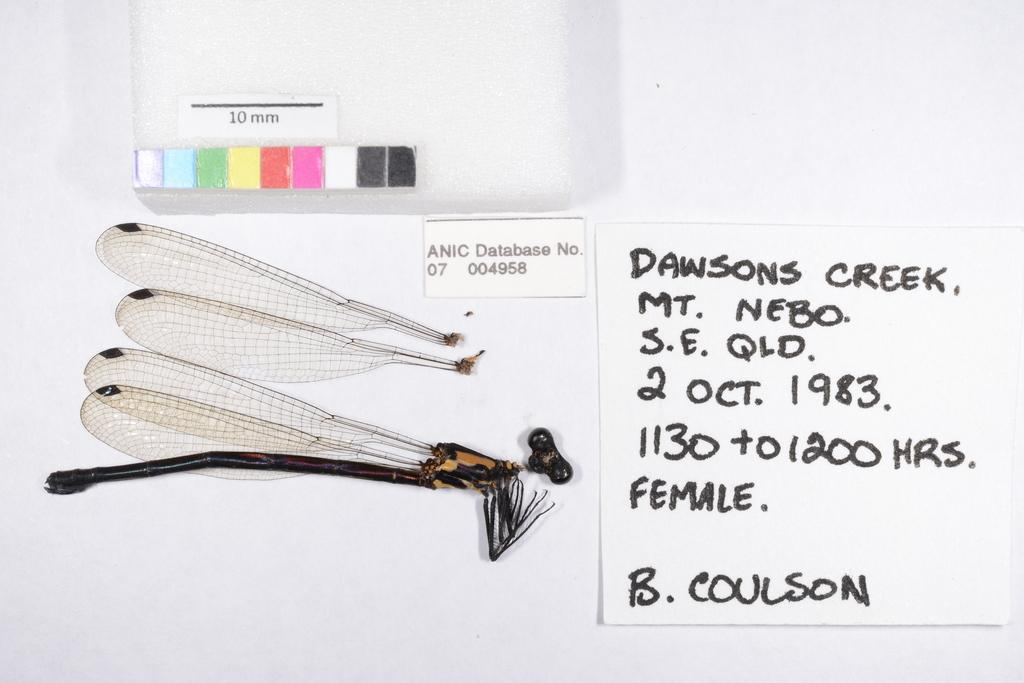What type of creature is present in the image? There is an insect in the image. What feature is visible on the insect? There are wings visible in the image. Can you describe the color scheme of the image? There are colors present in the image. What is written in the image? There is something written in the image. What color is the background of the image? The background of the image is white. What time of day does the ladybug desire to fly in the image? There is no ladybug present in the image, and therefore no such desire can be observed. 